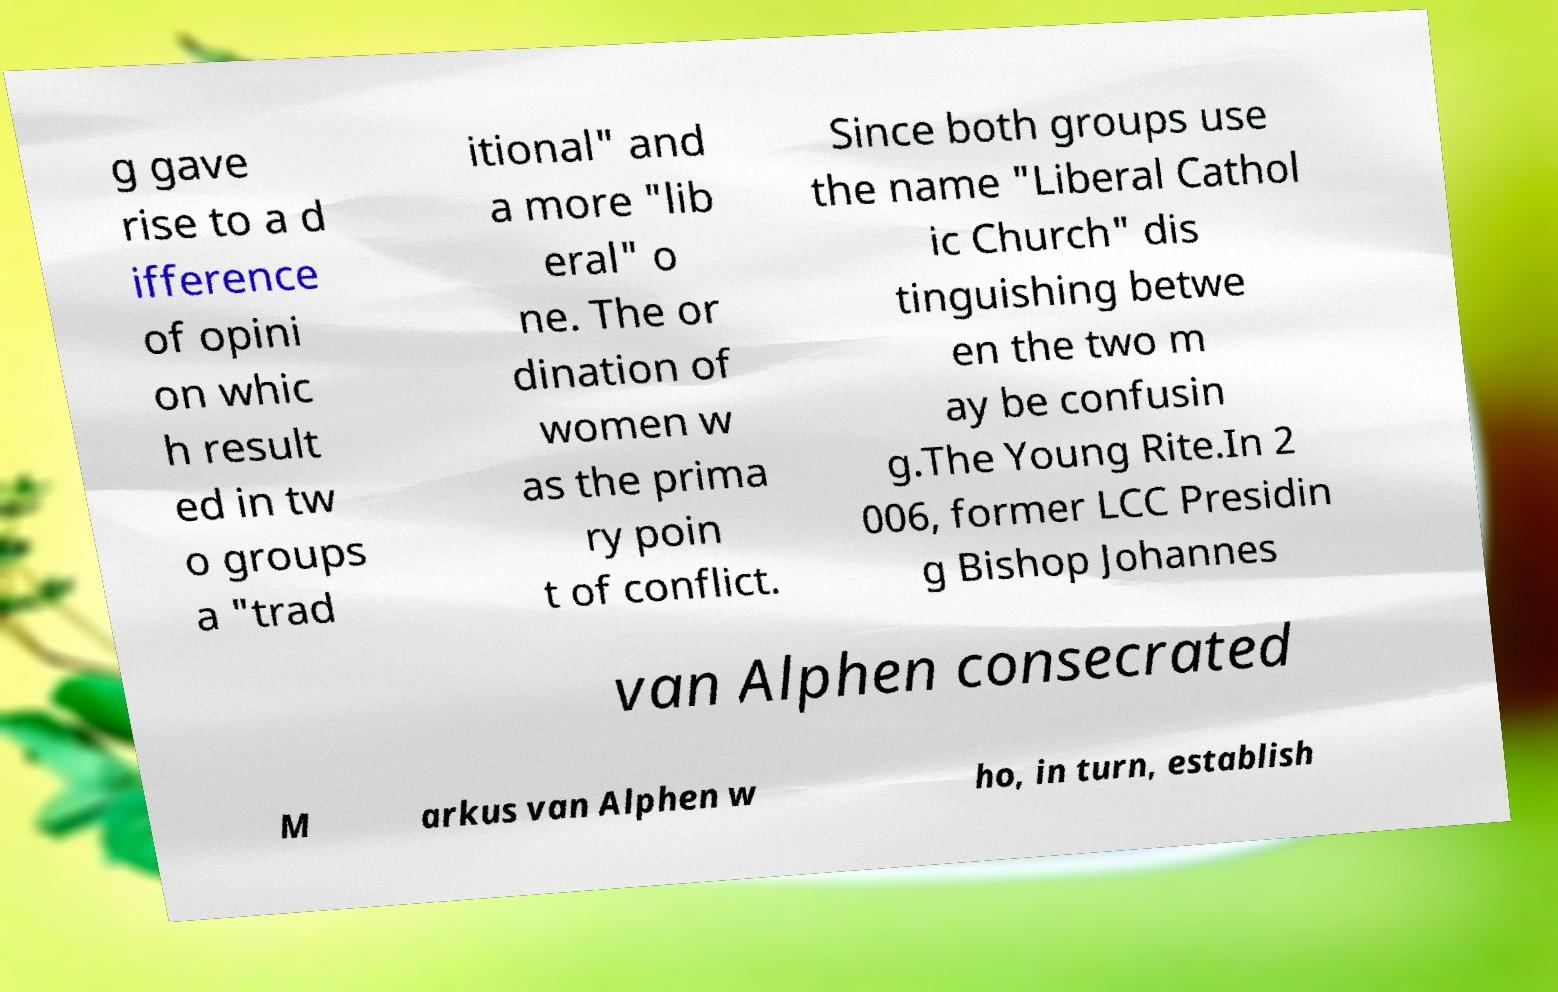Can you read and provide the text displayed in the image?This photo seems to have some interesting text. Can you extract and type it out for me? g gave rise to a d ifference of opini on whic h result ed in tw o groups a "trad itional" and a more "lib eral" o ne. The or dination of women w as the prima ry poin t of conflict. Since both groups use the name "Liberal Cathol ic Church" dis tinguishing betwe en the two m ay be confusin g.The Young Rite.In 2 006, former LCC Presidin g Bishop Johannes van Alphen consecrated M arkus van Alphen w ho, in turn, establish 